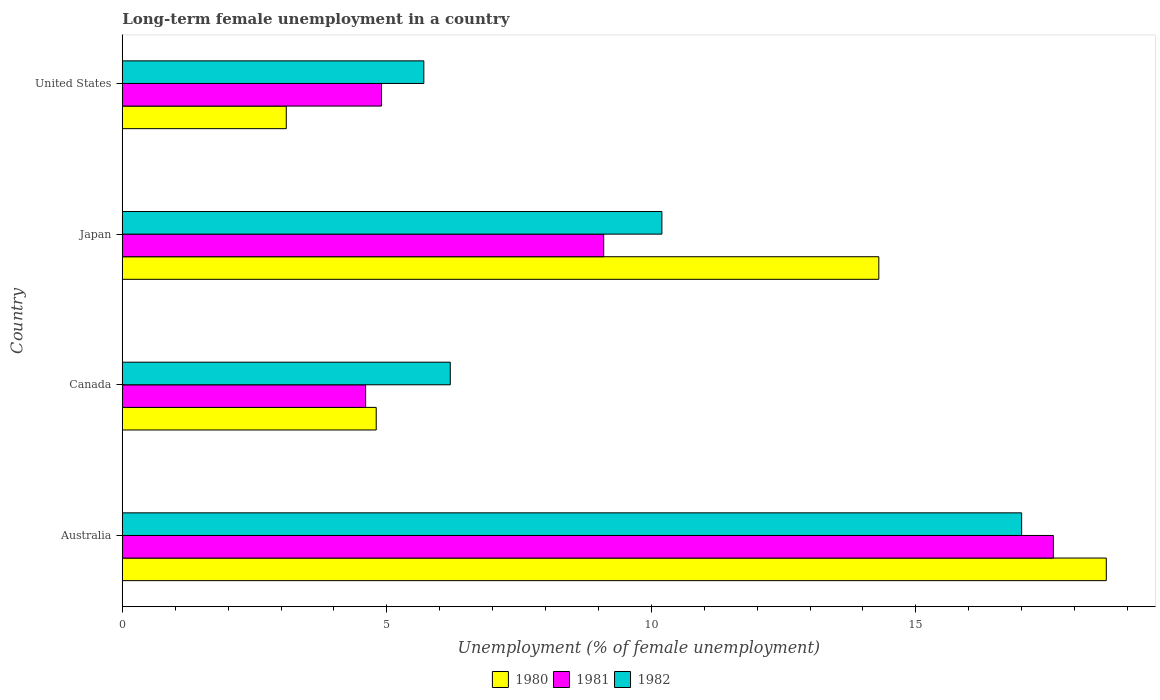How many different coloured bars are there?
Your answer should be very brief. 3. How many groups of bars are there?
Make the answer very short. 4. How many bars are there on the 4th tick from the bottom?
Give a very brief answer. 3. In how many cases, is the number of bars for a given country not equal to the number of legend labels?
Your response must be concise. 0. What is the percentage of long-term unemployed female population in 1980 in United States?
Your answer should be very brief. 3.1. Across all countries, what is the maximum percentage of long-term unemployed female population in 1981?
Provide a succinct answer. 17.6. Across all countries, what is the minimum percentage of long-term unemployed female population in 1982?
Give a very brief answer. 5.7. In which country was the percentage of long-term unemployed female population in 1982 maximum?
Offer a very short reply. Australia. What is the total percentage of long-term unemployed female population in 1982 in the graph?
Give a very brief answer. 39.1. What is the difference between the percentage of long-term unemployed female population in 1980 in Australia and that in Japan?
Offer a very short reply. 4.3. What is the difference between the percentage of long-term unemployed female population in 1981 in Japan and the percentage of long-term unemployed female population in 1982 in Australia?
Offer a terse response. -7.9. What is the average percentage of long-term unemployed female population in 1980 per country?
Your response must be concise. 10.2. What is the difference between the percentage of long-term unemployed female population in 1982 and percentage of long-term unemployed female population in 1981 in Australia?
Ensure brevity in your answer.  -0.6. What is the ratio of the percentage of long-term unemployed female population in 1980 in Japan to that in United States?
Ensure brevity in your answer.  4.61. Is the percentage of long-term unemployed female population in 1980 in Australia less than that in United States?
Keep it short and to the point. No. What is the difference between the highest and the second highest percentage of long-term unemployed female population in 1981?
Ensure brevity in your answer.  8.5. What is the difference between the highest and the lowest percentage of long-term unemployed female population in 1980?
Offer a terse response. 15.5. In how many countries, is the percentage of long-term unemployed female population in 1982 greater than the average percentage of long-term unemployed female population in 1982 taken over all countries?
Offer a terse response. 2. Is it the case that in every country, the sum of the percentage of long-term unemployed female population in 1981 and percentage of long-term unemployed female population in 1982 is greater than the percentage of long-term unemployed female population in 1980?
Offer a very short reply. Yes. How many bars are there?
Keep it short and to the point. 12. Are all the bars in the graph horizontal?
Your answer should be very brief. Yes. Does the graph contain grids?
Ensure brevity in your answer.  No. How many legend labels are there?
Give a very brief answer. 3. What is the title of the graph?
Ensure brevity in your answer.  Long-term female unemployment in a country. What is the label or title of the X-axis?
Offer a terse response. Unemployment (% of female unemployment). What is the label or title of the Y-axis?
Your response must be concise. Country. What is the Unemployment (% of female unemployment) of 1980 in Australia?
Provide a succinct answer. 18.6. What is the Unemployment (% of female unemployment) in 1981 in Australia?
Provide a short and direct response. 17.6. What is the Unemployment (% of female unemployment) in 1982 in Australia?
Provide a short and direct response. 17. What is the Unemployment (% of female unemployment) in 1980 in Canada?
Make the answer very short. 4.8. What is the Unemployment (% of female unemployment) of 1981 in Canada?
Offer a very short reply. 4.6. What is the Unemployment (% of female unemployment) of 1982 in Canada?
Ensure brevity in your answer.  6.2. What is the Unemployment (% of female unemployment) in 1980 in Japan?
Ensure brevity in your answer.  14.3. What is the Unemployment (% of female unemployment) in 1981 in Japan?
Your answer should be compact. 9.1. What is the Unemployment (% of female unemployment) of 1982 in Japan?
Make the answer very short. 10.2. What is the Unemployment (% of female unemployment) in 1980 in United States?
Offer a very short reply. 3.1. What is the Unemployment (% of female unemployment) in 1981 in United States?
Your response must be concise. 4.9. What is the Unemployment (% of female unemployment) in 1982 in United States?
Provide a short and direct response. 5.7. Across all countries, what is the maximum Unemployment (% of female unemployment) in 1980?
Provide a short and direct response. 18.6. Across all countries, what is the maximum Unemployment (% of female unemployment) of 1981?
Offer a terse response. 17.6. Across all countries, what is the minimum Unemployment (% of female unemployment) of 1980?
Ensure brevity in your answer.  3.1. Across all countries, what is the minimum Unemployment (% of female unemployment) of 1981?
Your answer should be very brief. 4.6. Across all countries, what is the minimum Unemployment (% of female unemployment) in 1982?
Offer a very short reply. 5.7. What is the total Unemployment (% of female unemployment) of 1980 in the graph?
Your response must be concise. 40.8. What is the total Unemployment (% of female unemployment) in 1981 in the graph?
Your answer should be compact. 36.2. What is the total Unemployment (% of female unemployment) in 1982 in the graph?
Provide a succinct answer. 39.1. What is the difference between the Unemployment (% of female unemployment) in 1981 in Australia and that in Canada?
Your answer should be compact. 13. What is the difference between the Unemployment (% of female unemployment) in 1982 in Australia and that in Canada?
Provide a succinct answer. 10.8. What is the difference between the Unemployment (% of female unemployment) of 1980 in Australia and that in United States?
Ensure brevity in your answer.  15.5. What is the difference between the Unemployment (% of female unemployment) of 1981 in Australia and that in United States?
Provide a short and direct response. 12.7. What is the difference between the Unemployment (% of female unemployment) of 1980 in Canada and that in Japan?
Provide a short and direct response. -9.5. What is the difference between the Unemployment (% of female unemployment) in 1982 in Canada and that in Japan?
Keep it short and to the point. -4. What is the difference between the Unemployment (% of female unemployment) of 1980 in Canada and that in United States?
Your answer should be compact. 1.7. What is the difference between the Unemployment (% of female unemployment) in 1981 in Canada and that in United States?
Ensure brevity in your answer.  -0.3. What is the difference between the Unemployment (% of female unemployment) of 1982 in Canada and that in United States?
Provide a short and direct response. 0.5. What is the difference between the Unemployment (% of female unemployment) in 1981 in Japan and that in United States?
Make the answer very short. 4.2. What is the difference between the Unemployment (% of female unemployment) of 1982 in Japan and that in United States?
Offer a terse response. 4.5. What is the difference between the Unemployment (% of female unemployment) in 1980 in Australia and the Unemployment (% of female unemployment) in 1981 in Canada?
Offer a terse response. 14. What is the difference between the Unemployment (% of female unemployment) of 1980 in Australia and the Unemployment (% of female unemployment) of 1982 in Canada?
Give a very brief answer. 12.4. What is the difference between the Unemployment (% of female unemployment) in 1980 in Australia and the Unemployment (% of female unemployment) in 1982 in Japan?
Offer a very short reply. 8.4. What is the difference between the Unemployment (% of female unemployment) in 1981 in Canada and the Unemployment (% of female unemployment) in 1982 in Japan?
Your answer should be compact. -5.6. What is the difference between the Unemployment (% of female unemployment) in 1980 in Canada and the Unemployment (% of female unemployment) in 1981 in United States?
Offer a very short reply. -0.1. What is the difference between the Unemployment (% of female unemployment) of 1981 in Canada and the Unemployment (% of female unemployment) of 1982 in United States?
Offer a terse response. -1.1. What is the difference between the Unemployment (% of female unemployment) in 1980 in Japan and the Unemployment (% of female unemployment) in 1981 in United States?
Make the answer very short. 9.4. What is the difference between the Unemployment (% of female unemployment) in 1980 in Japan and the Unemployment (% of female unemployment) in 1982 in United States?
Provide a short and direct response. 8.6. What is the difference between the Unemployment (% of female unemployment) of 1981 in Japan and the Unemployment (% of female unemployment) of 1982 in United States?
Provide a short and direct response. 3.4. What is the average Unemployment (% of female unemployment) of 1980 per country?
Ensure brevity in your answer.  10.2. What is the average Unemployment (% of female unemployment) of 1981 per country?
Make the answer very short. 9.05. What is the average Unemployment (% of female unemployment) in 1982 per country?
Provide a short and direct response. 9.78. What is the difference between the Unemployment (% of female unemployment) in 1980 and Unemployment (% of female unemployment) in 1982 in Australia?
Ensure brevity in your answer.  1.6. What is the difference between the Unemployment (% of female unemployment) in 1980 and Unemployment (% of female unemployment) in 1982 in Canada?
Provide a short and direct response. -1.4. What is the difference between the Unemployment (% of female unemployment) in 1981 and Unemployment (% of female unemployment) in 1982 in Canada?
Your response must be concise. -1.6. What is the difference between the Unemployment (% of female unemployment) in 1981 and Unemployment (% of female unemployment) in 1982 in Japan?
Your answer should be compact. -1.1. What is the difference between the Unemployment (% of female unemployment) of 1981 and Unemployment (% of female unemployment) of 1982 in United States?
Your answer should be compact. -0.8. What is the ratio of the Unemployment (% of female unemployment) of 1980 in Australia to that in Canada?
Ensure brevity in your answer.  3.88. What is the ratio of the Unemployment (% of female unemployment) of 1981 in Australia to that in Canada?
Your response must be concise. 3.83. What is the ratio of the Unemployment (% of female unemployment) in 1982 in Australia to that in Canada?
Ensure brevity in your answer.  2.74. What is the ratio of the Unemployment (% of female unemployment) in 1980 in Australia to that in Japan?
Your answer should be very brief. 1.3. What is the ratio of the Unemployment (% of female unemployment) in 1981 in Australia to that in Japan?
Your answer should be compact. 1.93. What is the ratio of the Unemployment (% of female unemployment) of 1982 in Australia to that in Japan?
Ensure brevity in your answer.  1.67. What is the ratio of the Unemployment (% of female unemployment) of 1981 in Australia to that in United States?
Provide a short and direct response. 3.59. What is the ratio of the Unemployment (% of female unemployment) of 1982 in Australia to that in United States?
Your response must be concise. 2.98. What is the ratio of the Unemployment (% of female unemployment) of 1980 in Canada to that in Japan?
Your answer should be compact. 0.34. What is the ratio of the Unemployment (% of female unemployment) in 1981 in Canada to that in Japan?
Make the answer very short. 0.51. What is the ratio of the Unemployment (% of female unemployment) in 1982 in Canada to that in Japan?
Your answer should be very brief. 0.61. What is the ratio of the Unemployment (% of female unemployment) in 1980 in Canada to that in United States?
Make the answer very short. 1.55. What is the ratio of the Unemployment (% of female unemployment) of 1981 in Canada to that in United States?
Ensure brevity in your answer.  0.94. What is the ratio of the Unemployment (% of female unemployment) in 1982 in Canada to that in United States?
Your response must be concise. 1.09. What is the ratio of the Unemployment (% of female unemployment) in 1980 in Japan to that in United States?
Your answer should be compact. 4.61. What is the ratio of the Unemployment (% of female unemployment) in 1981 in Japan to that in United States?
Offer a terse response. 1.86. What is the ratio of the Unemployment (% of female unemployment) of 1982 in Japan to that in United States?
Offer a terse response. 1.79. What is the difference between the highest and the second highest Unemployment (% of female unemployment) in 1980?
Your answer should be very brief. 4.3. What is the difference between the highest and the lowest Unemployment (% of female unemployment) in 1980?
Keep it short and to the point. 15.5. 